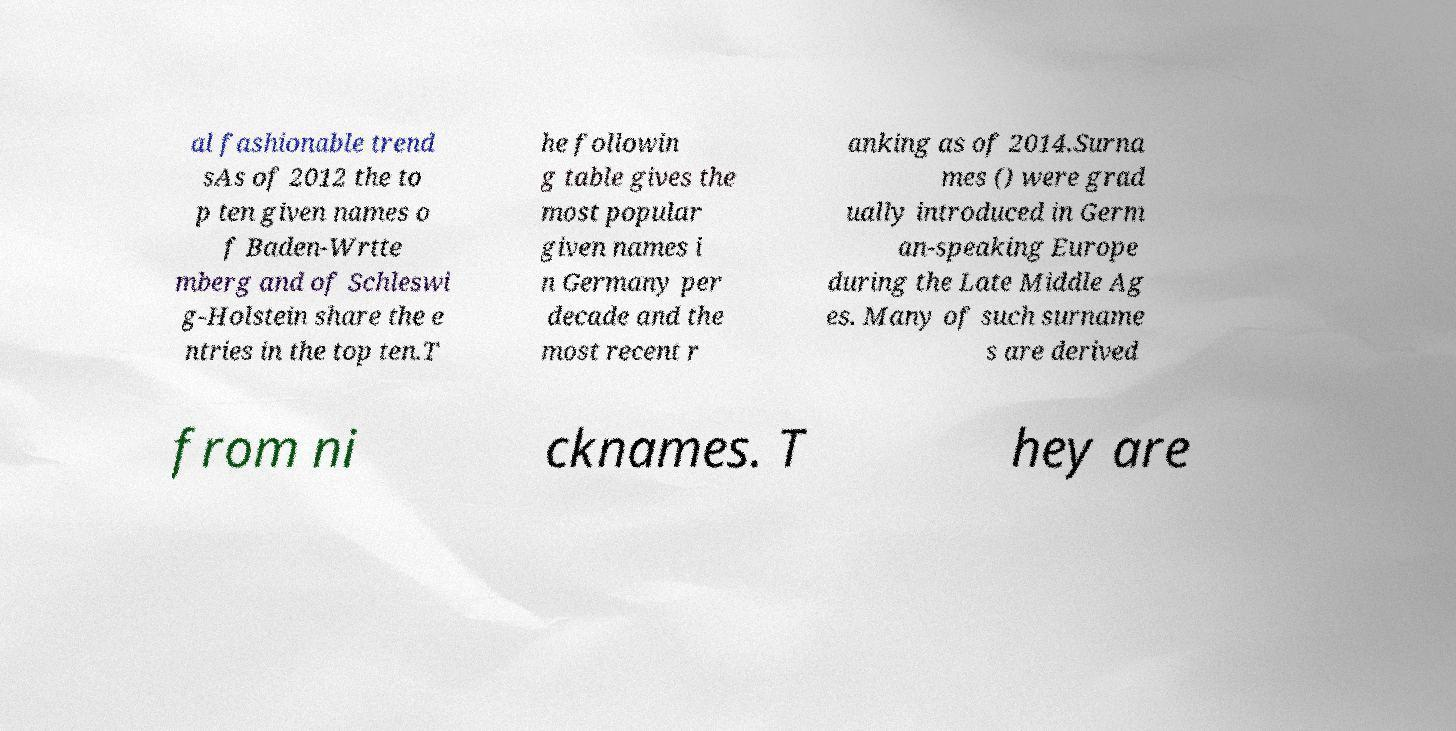Can you read and provide the text displayed in the image?This photo seems to have some interesting text. Can you extract and type it out for me? al fashionable trend sAs of 2012 the to p ten given names o f Baden-Wrtte mberg and of Schleswi g-Holstein share the e ntries in the top ten.T he followin g table gives the most popular given names i n Germany per decade and the most recent r anking as of 2014.Surna mes () were grad ually introduced in Germ an-speaking Europe during the Late Middle Ag es. Many of such surname s are derived from ni cknames. T hey are 